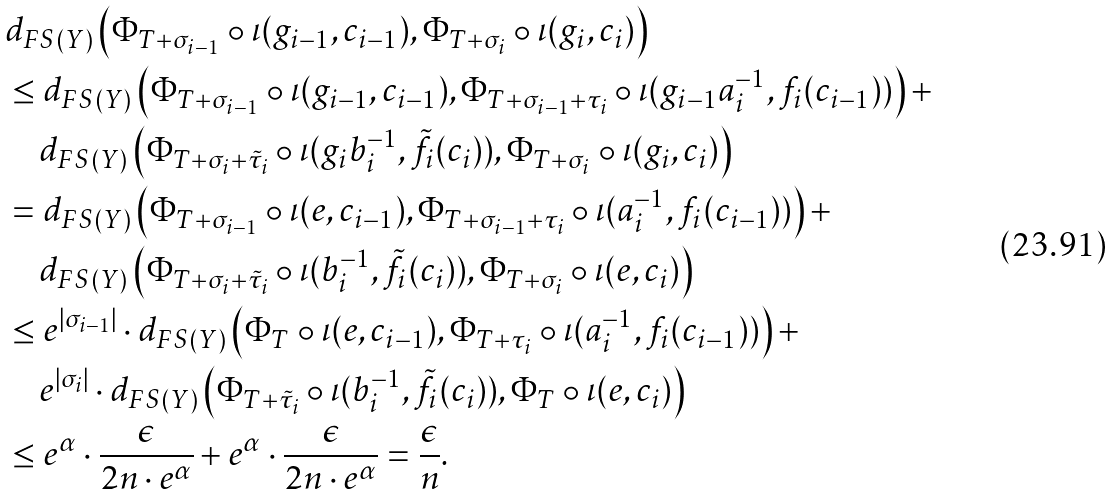Convert formula to latex. <formula><loc_0><loc_0><loc_500><loc_500>& d _ { F S ( Y ) } \left ( \Phi _ { T + \sigma _ { i - 1 } } \circ \iota ( g _ { i - 1 } , c _ { i - 1 } ) , \Phi _ { T + \sigma _ { i } } \circ \iota ( g _ { i } , c _ { i } ) \right ) \\ & \leq d _ { F S ( Y ) } \left ( \Phi _ { T + \sigma _ { i - 1 } } \circ \iota ( g _ { i - 1 } , c _ { i - 1 } ) , \Phi _ { T + \sigma _ { i - 1 } + \tau _ { i } } \circ \iota ( g _ { i - 1 } a _ { i } ^ { - 1 } , f _ { i } ( c _ { i - 1 } ) ) \right ) + \\ & \quad d _ { F S ( Y ) } \left ( \Phi _ { T + \sigma _ { i } + \tilde { \tau } _ { i } } \circ \iota ( g _ { i } b _ { i } ^ { - 1 } , \tilde { f } _ { i } ( c _ { i } ) ) , \Phi _ { T + \sigma _ { i } } \circ \iota ( g _ { i } , c _ { i } ) \right ) \\ & = d _ { F S ( Y ) } \left ( \Phi _ { T + \sigma _ { i - 1 } } \circ \iota ( e , c _ { i - 1 } ) , \Phi _ { T + \sigma _ { i - 1 } + \tau _ { i } } \circ \iota ( a _ { i } ^ { - 1 } , f _ { i } ( c _ { i - 1 } ) ) \right ) + \\ & \quad d _ { F S ( Y ) } \left ( \Phi _ { T + \sigma _ { i } + \tilde { \tau } _ { i } } \circ \iota ( b _ { i } ^ { - 1 } , \tilde { f } _ { i } ( c _ { i } ) ) , \Phi _ { T + \sigma _ { i } } \circ \iota ( e , c _ { i } ) \right ) \\ & \leq e ^ { | \sigma _ { i - 1 } | } \cdot d _ { F S ( Y ) } \left ( \Phi _ { T } \circ \iota ( e , c _ { i - 1 } ) , \Phi _ { T + \tau _ { i } } \circ \iota ( a _ { i } ^ { - 1 } , f _ { i } ( c _ { i - 1 } ) ) \right ) + \\ & \quad e ^ { | \sigma _ { i } | } \cdot d _ { F S ( Y ) } \left ( \Phi _ { T + \tilde { \tau } _ { i } } \circ \iota ( b _ { i } ^ { - 1 } , \tilde { f } _ { i } ( c _ { i } ) ) , \Phi _ { T } \circ \iota ( e , c _ { i } ) \right ) \\ & \leq e ^ { \alpha } \cdot \frac { \epsilon } { 2 n \cdot e ^ { \alpha } } + e ^ { \alpha } \cdot \frac { \epsilon } { 2 n \cdot e ^ { \alpha } } = \frac { \epsilon } { n } .</formula> 